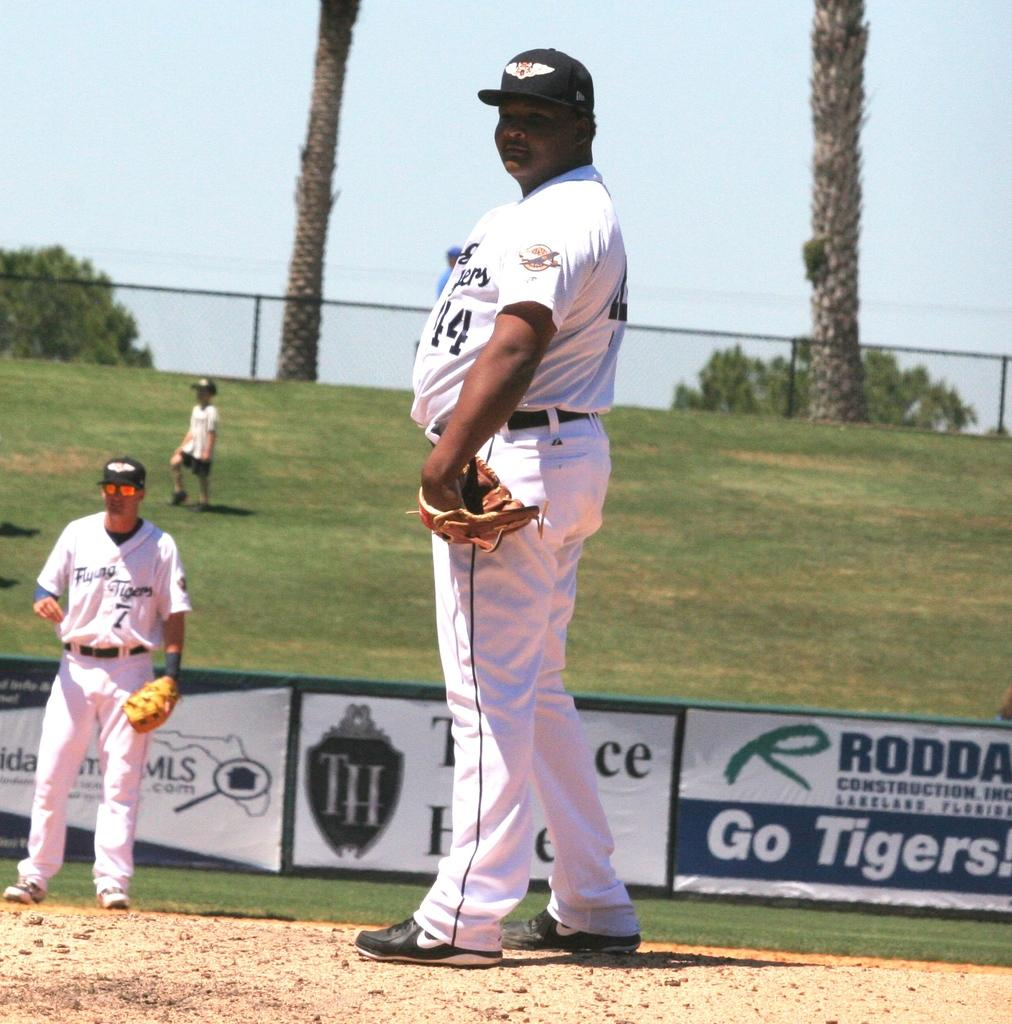<image>
Write a terse but informative summary of the picture. a man on the mound with a go tigers ad behind him 